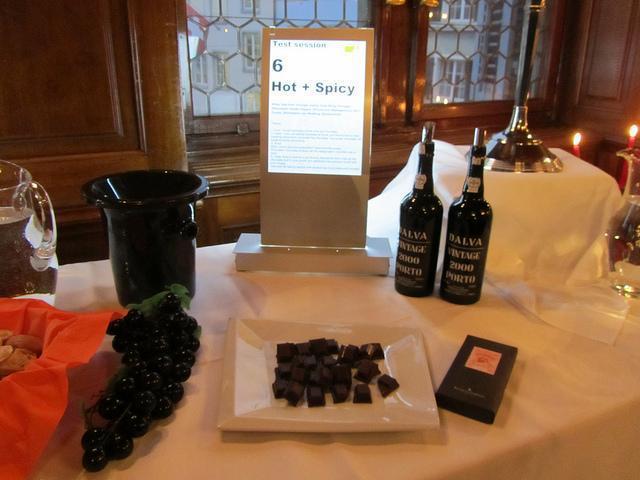How many bottles are there?
Give a very brief answer. 2. 